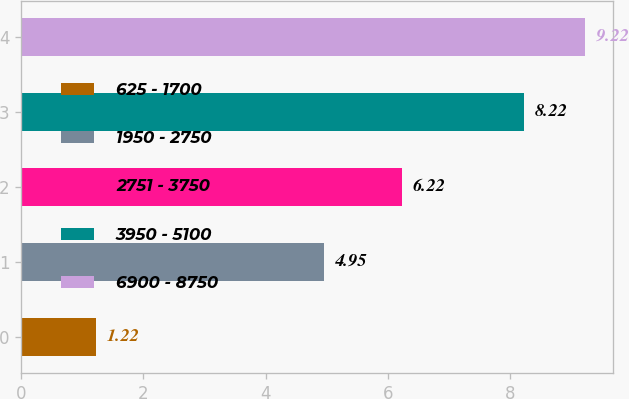Convert chart. <chart><loc_0><loc_0><loc_500><loc_500><bar_chart><fcel>625 - 1700<fcel>1950 - 2750<fcel>2751 - 3750<fcel>3950 - 5100<fcel>6900 - 8750<nl><fcel>1.22<fcel>4.95<fcel>6.22<fcel>8.22<fcel>9.22<nl></chart> 